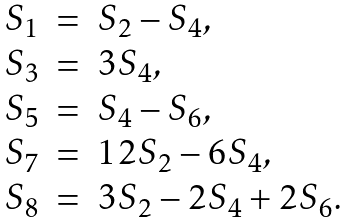Convert formula to latex. <formula><loc_0><loc_0><loc_500><loc_500>\begin{array} { l l l } S _ { 1 } & = & S _ { 2 } - S _ { 4 } , \\ S _ { 3 } & = & 3 S _ { 4 } , \\ S _ { 5 } & = & S _ { 4 } - S _ { 6 } , \\ S _ { 7 } & = & 1 2 S _ { 2 } - 6 S _ { 4 } , \\ S _ { 8 } & = & 3 S _ { 2 } - 2 S _ { 4 } + 2 S _ { 6 } . \end{array}</formula> 